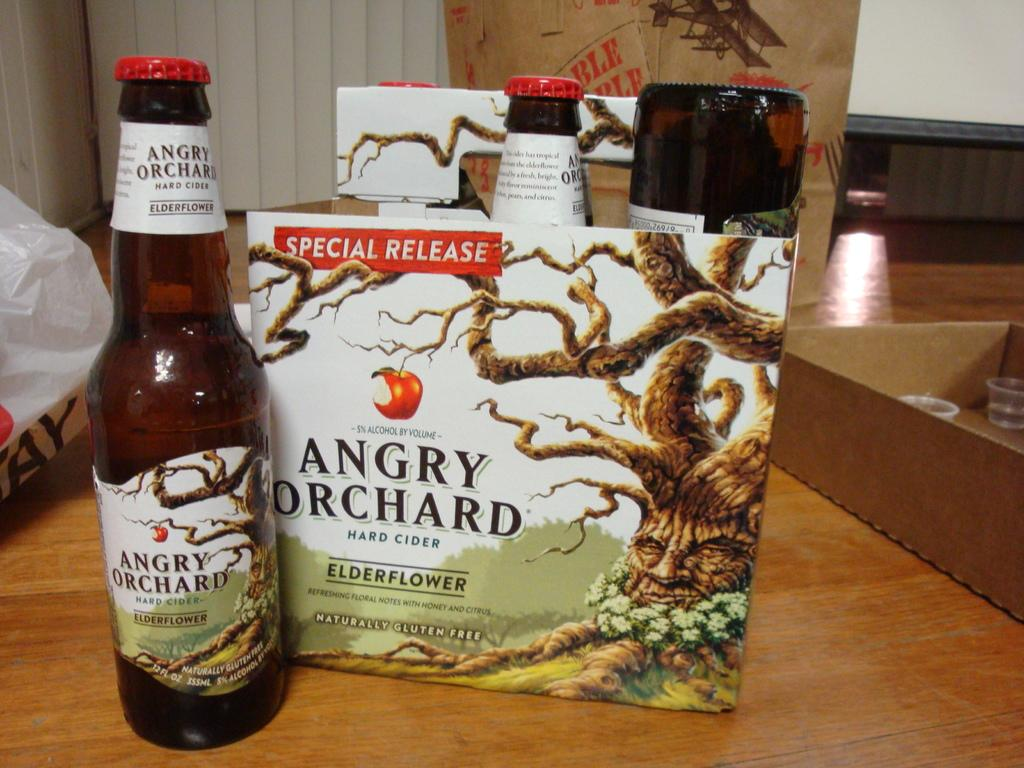<image>
Describe the image concisely. A special release package of Angry Orchard sits on a table. 